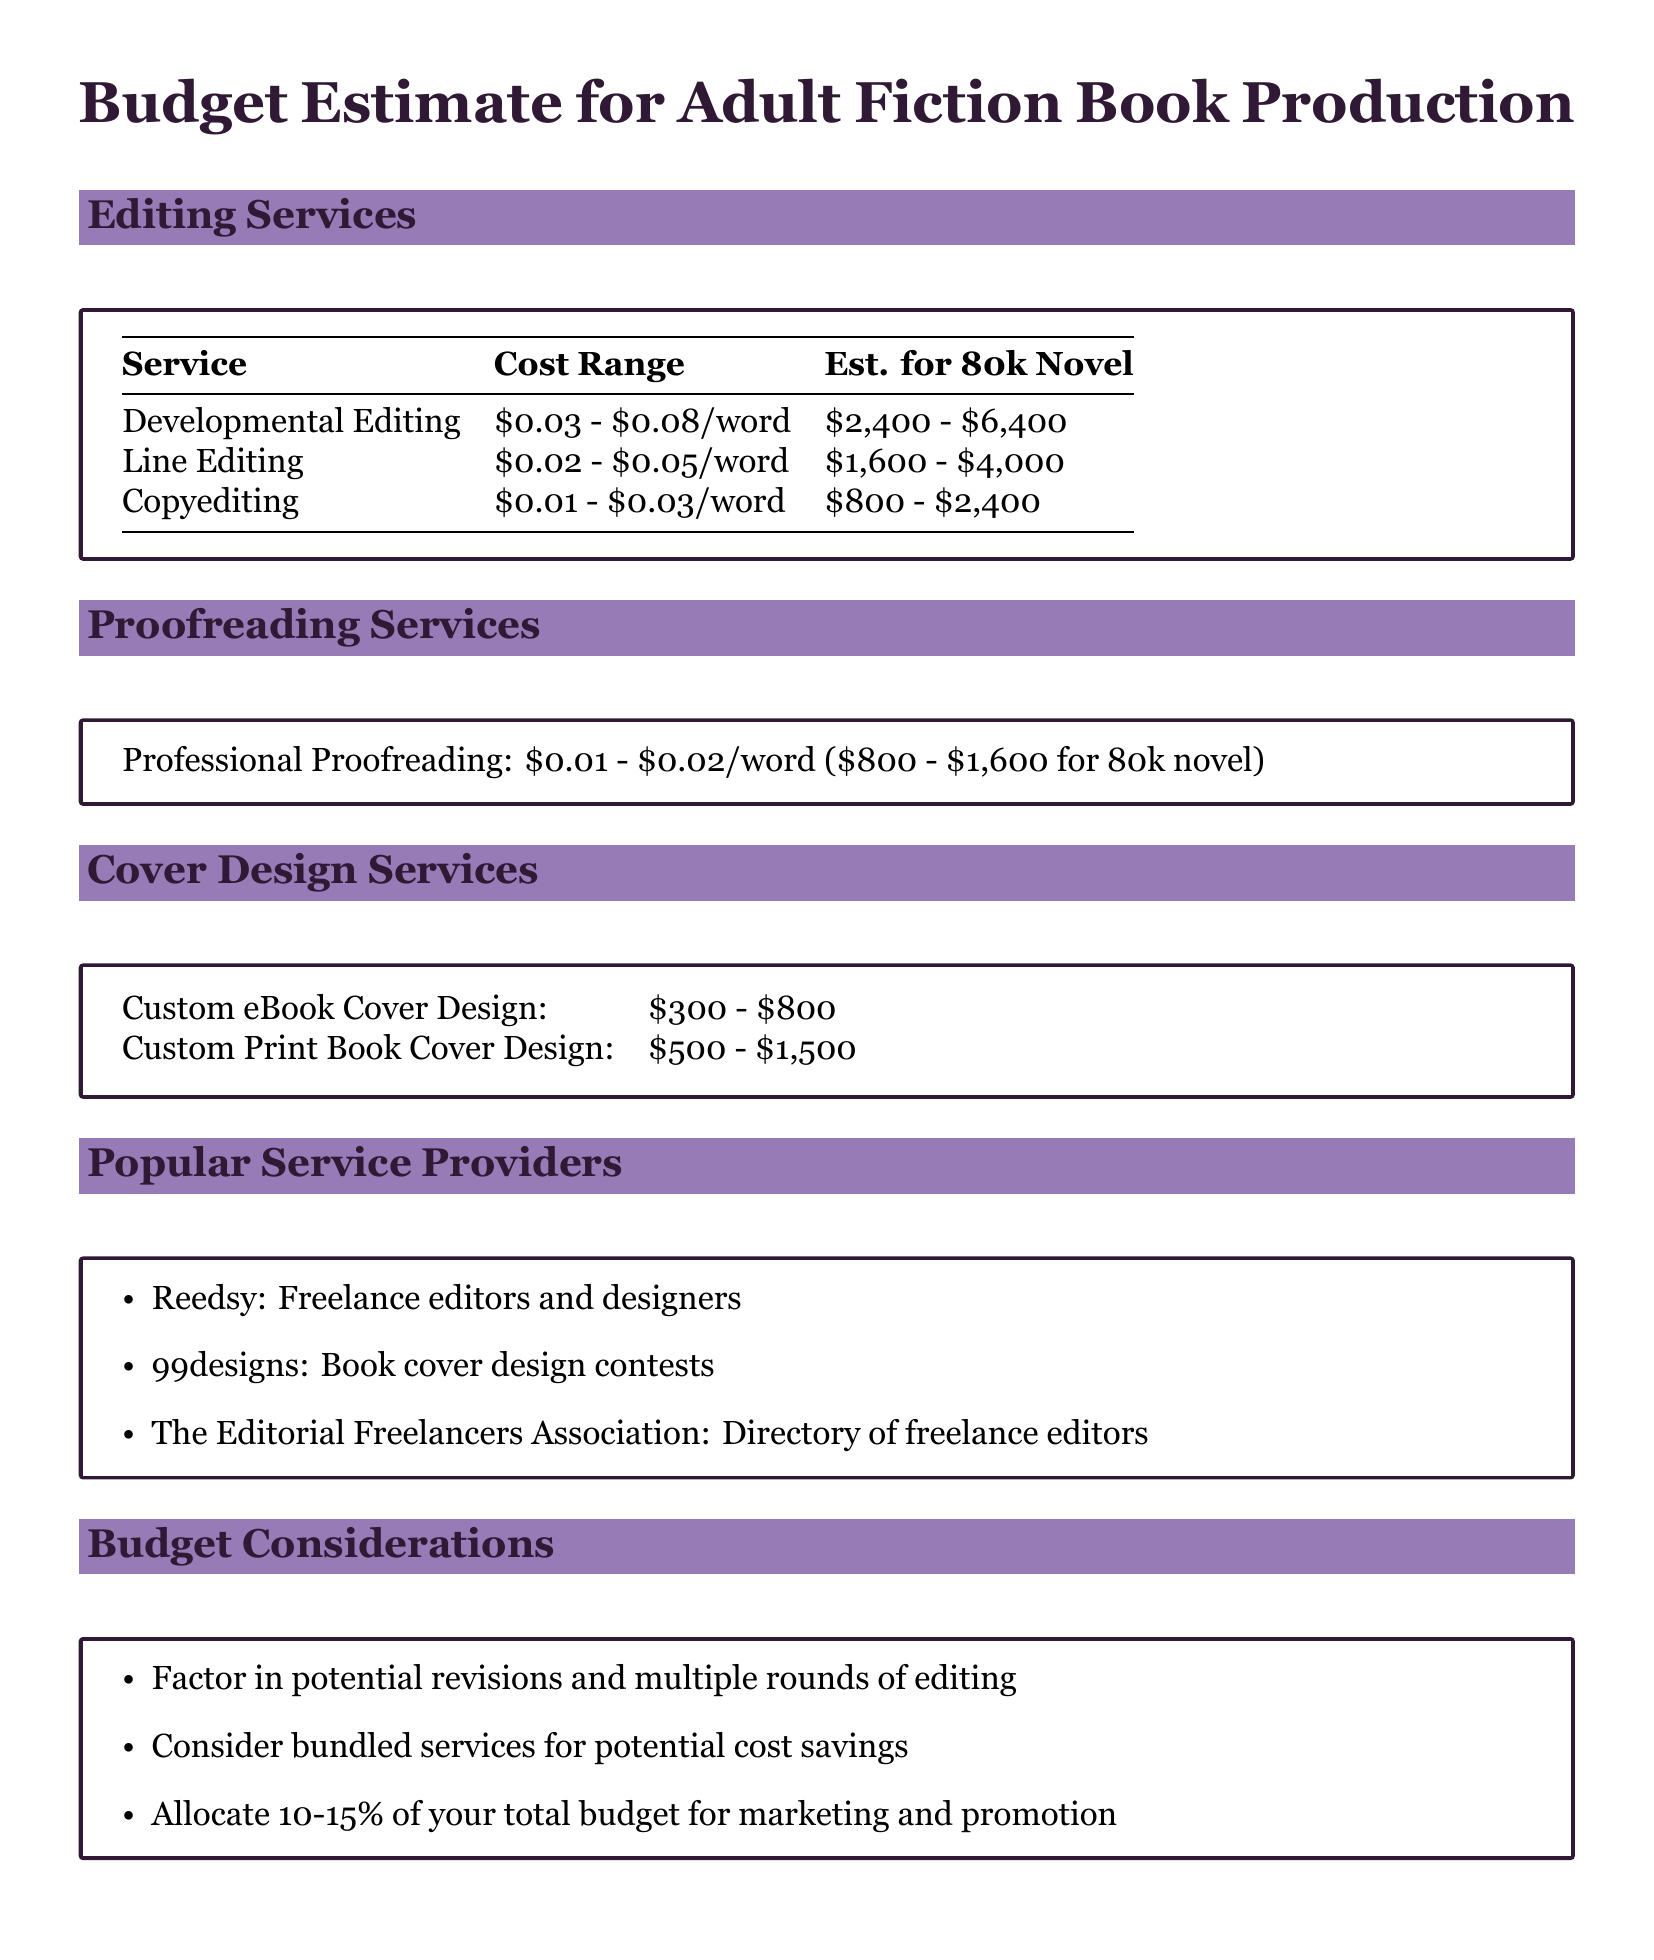What is the cost range for developmental editing? The cost range for developmental editing is \$0.03 - \$0.08 per word.
Answer: \$0.03 - \$0.08/word What is the estimated cost for line editing of an 80k novel? The estimated cost for line editing an 80k novel is discussed in the table.
Answer: \$1,600 - \$4,000 What is the cost range for custom eBook cover design? The cost range for custom eBook cover design is shown in the budget box.
Answer: \$300 - \$800 What percentage of the total budget should be allocated for marketing and promotion? The document suggests allocating a specific percentage for marketing.
Answer: 10-15% Name one popular service provider for freelance editors. The document lists various service providers for editing and design.
Answer: Reedsy What is the estimated cost for proofreading an 80k novel? The estimated cost for professional proofreading is mentioned in the proofreading services section.
Answer: \$800 - \$1,600 What should authors consider for potential cost savings? The budget considerations section mentions ways to optimize spending.
Answer: Bundled services How many types of editing services are listed in the document? The document includes a variety of editing services, indicating their range.
Answer: Three types 